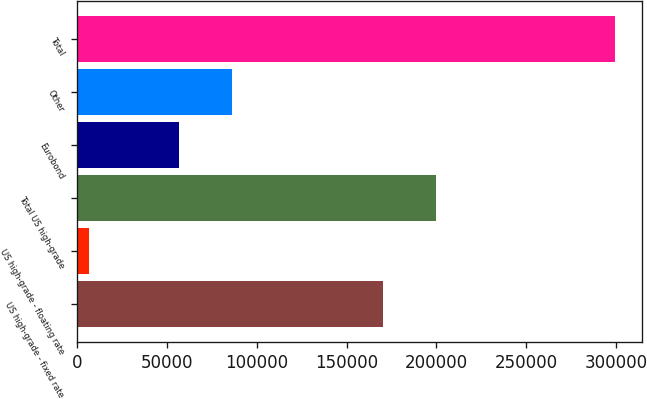Convert chart. <chart><loc_0><loc_0><loc_500><loc_500><bar_chart><fcel>US high-grade - fixed rate<fcel>US high-grade - floating rate<fcel>Total US high-grade<fcel>Eurobond<fcel>Other<fcel>Total<nl><fcel>170519<fcel>6629<fcel>199785<fcel>56778<fcel>86043.7<fcel>299286<nl></chart> 